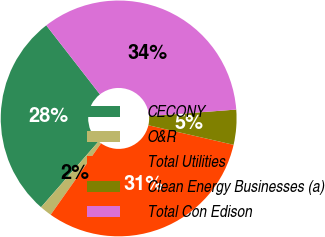Convert chart to OTSL. <chart><loc_0><loc_0><loc_500><loc_500><pie_chart><fcel>CECONY<fcel>O&R<fcel>Total Utilities<fcel>Clean Energy Businesses (a)<fcel>Total Con Edison<nl><fcel>28.05%<fcel>1.65%<fcel>31.19%<fcel>4.79%<fcel>34.32%<nl></chart> 